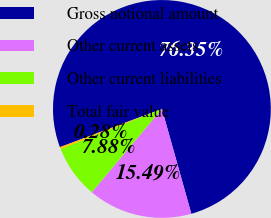Convert chart. <chart><loc_0><loc_0><loc_500><loc_500><pie_chart><fcel>Gross notional amount<fcel>Other current assets<fcel>Other current liabilities<fcel>Total fair value<nl><fcel>76.35%<fcel>15.49%<fcel>7.88%<fcel>0.28%<nl></chart> 